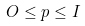Convert formula to latex. <formula><loc_0><loc_0><loc_500><loc_500>O \leq p \leq I</formula> 